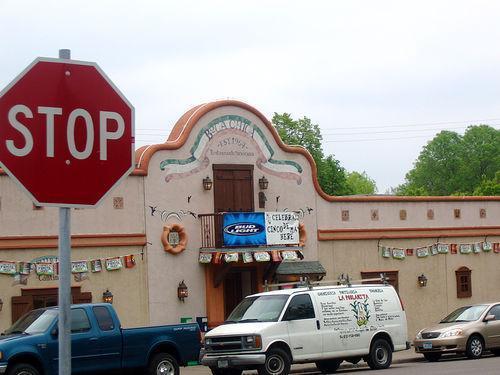How many people are skiing down the hill?
Give a very brief answer. 0. 